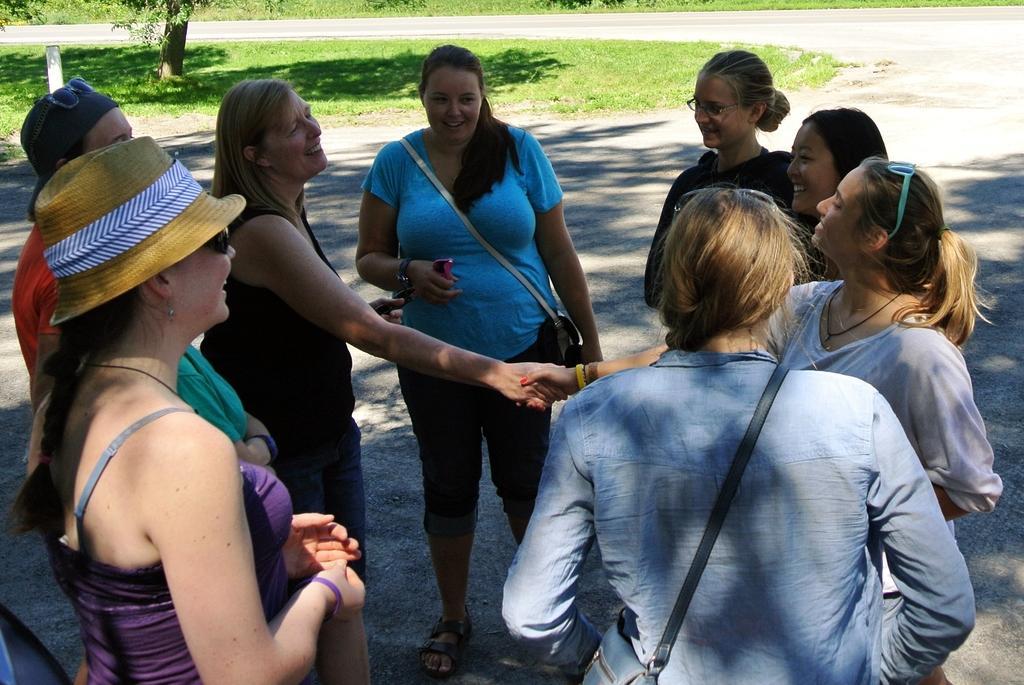What are the women in the image doing? The women are standing in a circle and handshaking. What can be seen in the background of the image? There is a road, grass, a pole, and trees visible in the background. How many women are present in the image? The number of women is not specified, but they are standing in a circle, which suggests there are at least three or more. What type of egg is being used as a prop in the image? There is no egg present in the image; the women are handshaking in a circle. What color are the trousers worn by the women in the image? The clothing worn by the women is not specified in the image, so we cannot determine the color of their trousers. 